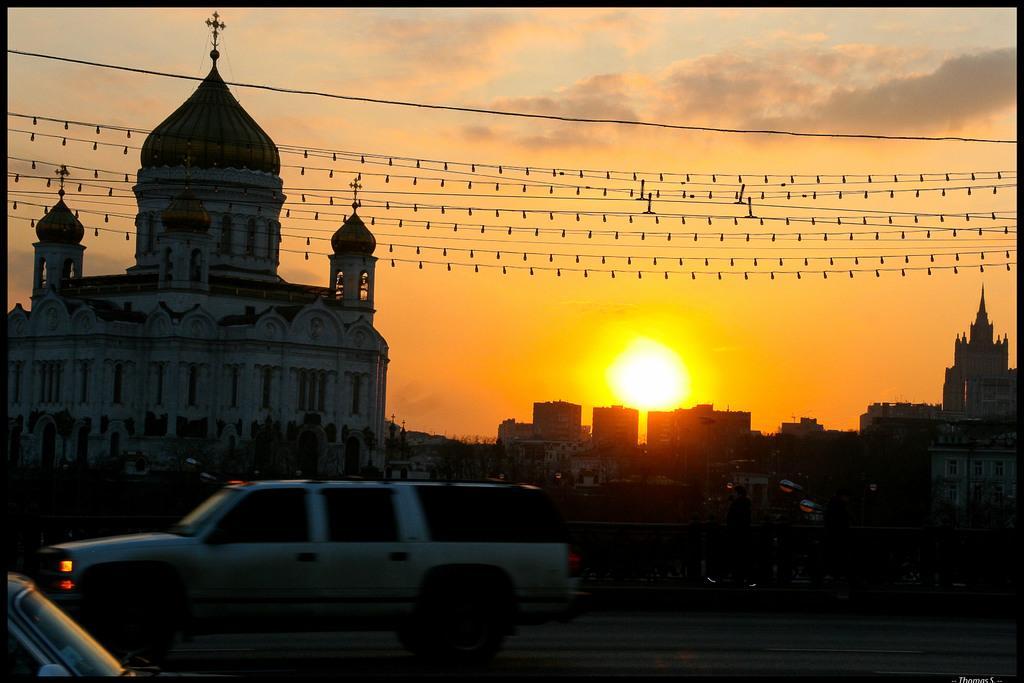Can you describe this image briefly? In this image we can see a group of buildings, a fence and some vehicles on the road. We can also see the sun, some wires with lights and the sky which looks cloudy. 